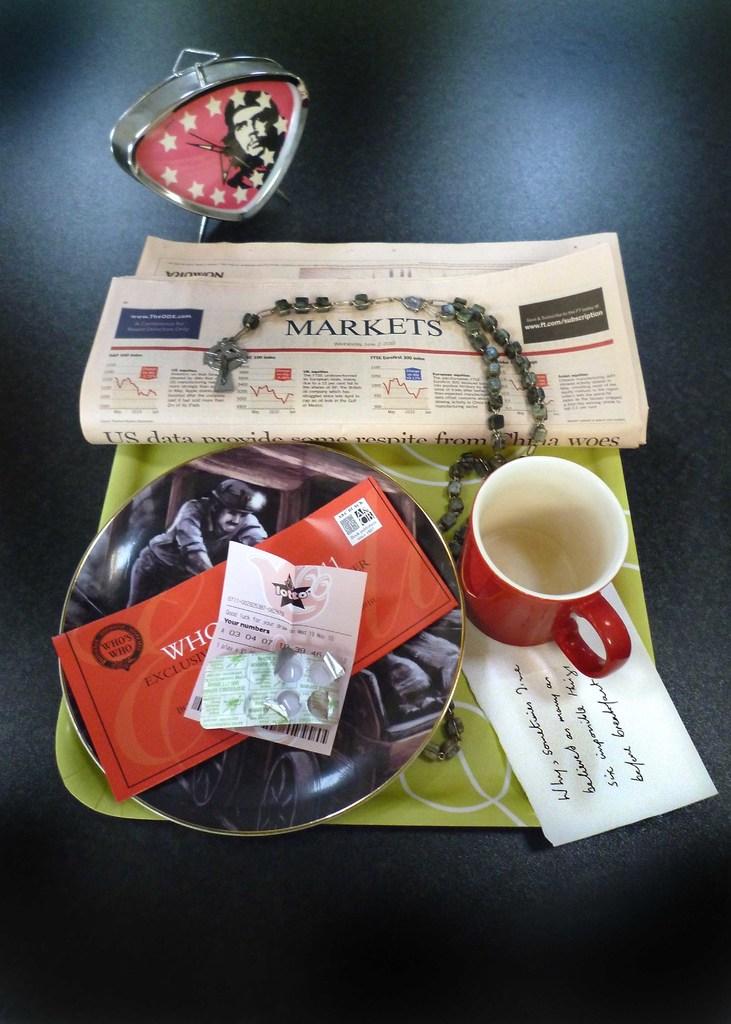What is the newspaper section talking about?
Your answer should be very brief. Markets. 